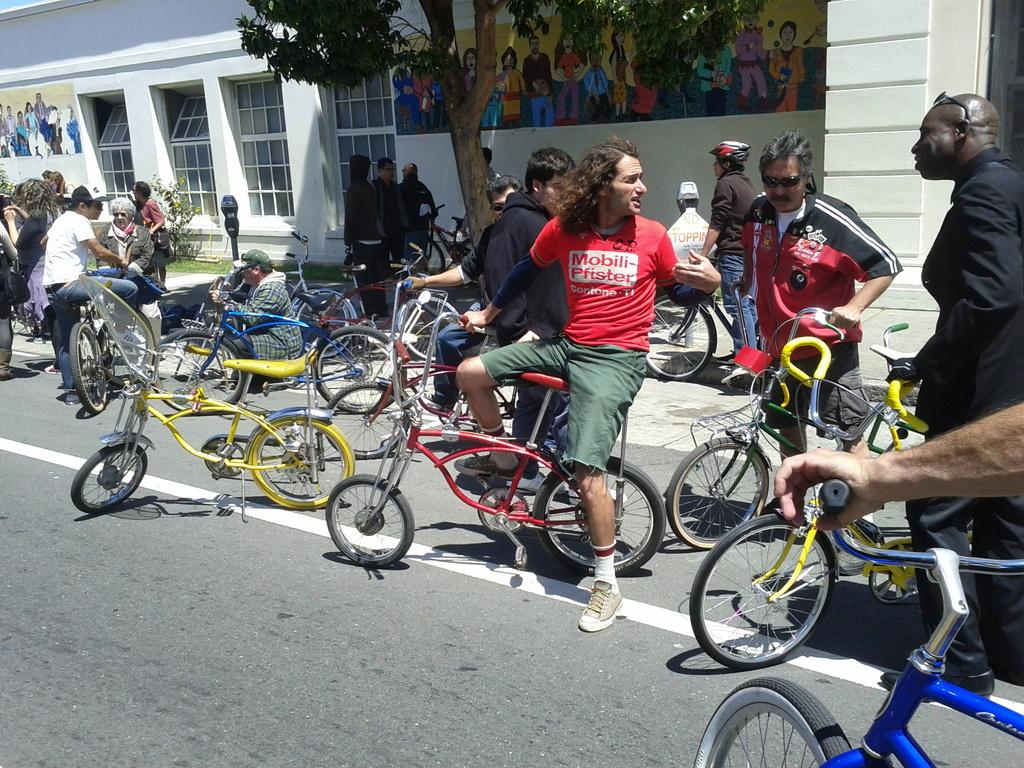Who or what can be seen in the image? There are people in the image. What are the people doing in the image? The image does not provide enough information to determine what the people are doing. What can be seen on the road in the image? There are bicycles on the road in the image. What is visible in the background of the image? There is a building, trees, and posters in the background of the image. What type of joke can be heard in the background of the image? There is no audible information in the image, so it is not possible to determine if a joke is being told or heard. 